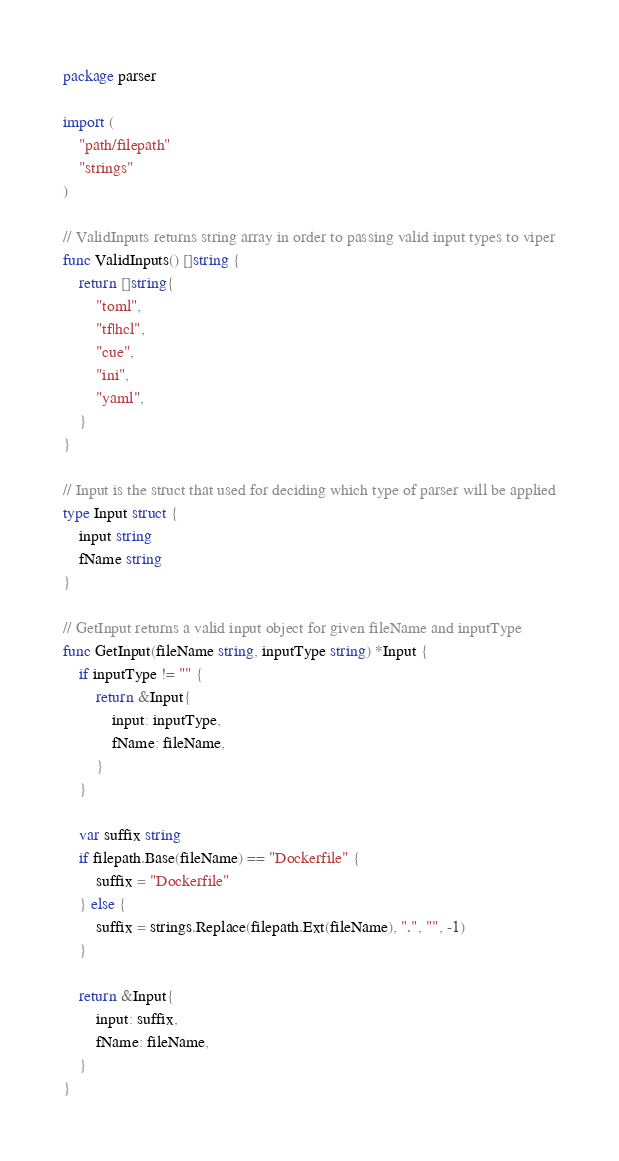<code> <loc_0><loc_0><loc_500><loc_500><_Go_>package parser

import (
	"path/filepath"
	"strings"
)

// ValidInputs returns string array in order to passing valid input types to viper
func ValidInputs() []string {
	return []string{
		"toml",
		"tf|hcl",
		"cue",
		"ini",
		"yaml",
	}
}

// Input is the struct that used for deciding which type of parser will be applied
type Input struct {
	input string
	fName string
}

// GetInput returns a valid input object for given fileName and inputType
func GetInput(fileName string, inputType string) *Input {
	if inputType != "" {
		return &Input{
			input: inputType,
			fName: fileName,
		}
	}

	var suffix string
	if filepath.Base(fileName) == "Dockerfile" {
		suffix = "Dockerfile"
	} else {
		suffix = strings.Replace(filepath.Ext(fileName), ".", "", -1)
	}
	
	return &Input{
		input: suffix,
		fName: fileName,
	}
}
</code> 